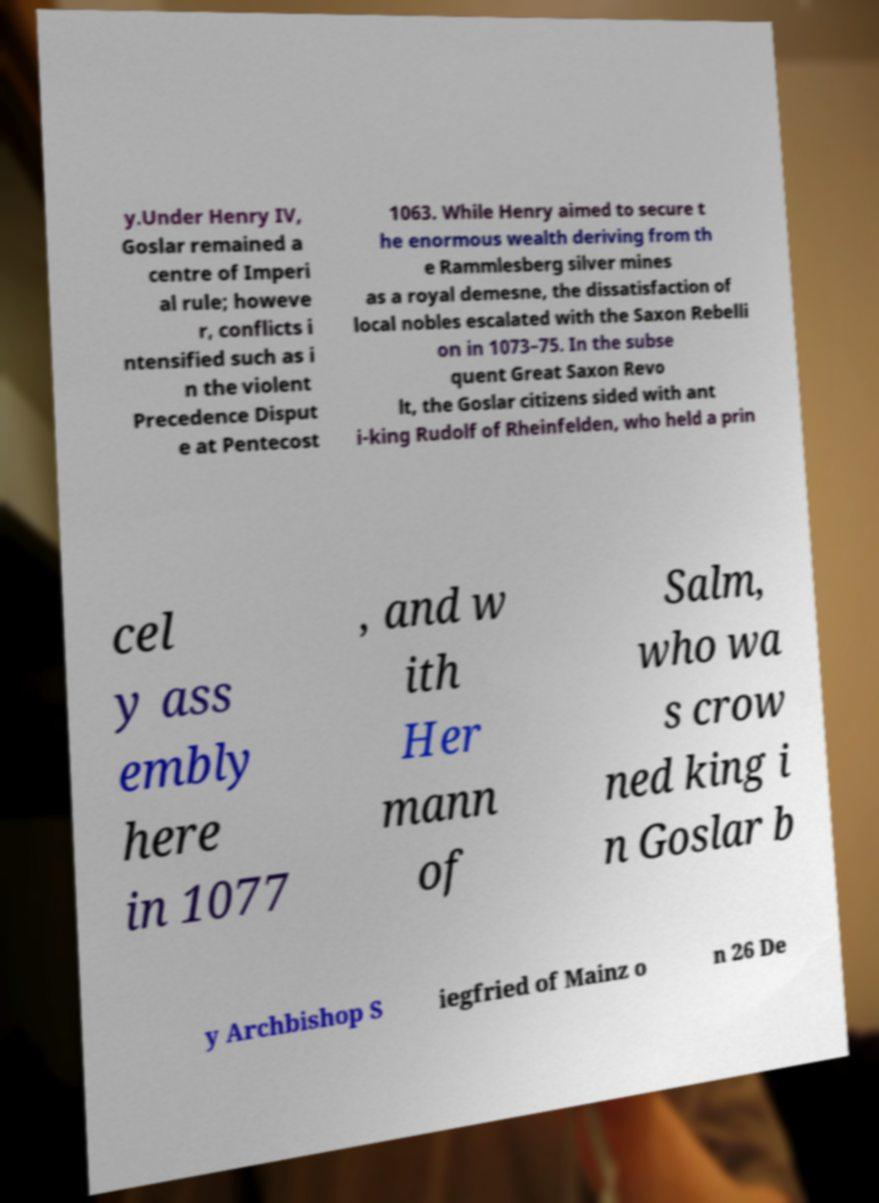For documentation purposes, I need the text within this image transcribed. Could you provide that? y.Under Henry IV, Goslar remained a centre of Imperi al rule; howeve r, conflicts i ntensified such as i n the violent Precedence Disput e at Pentecost 1063. While Henry aimed to secure t he enormous wealth deriving from th e Rammlesberg silver mines as a royal demesne, the dissatisfaction of local nobles escalated with the Saxon Rebelli on in 1073–75. In the subse quent Great Saxon Revo lt, the Goslar citizens sided with ant i-king Rudolf of Rheinfelden, who held a prin cel y ass embly here in 1077 , and w ith Her mann of Salm, who wa s crow ned king i n Goslar b y Archbishop S iegfried of Mainz o n 26 De 